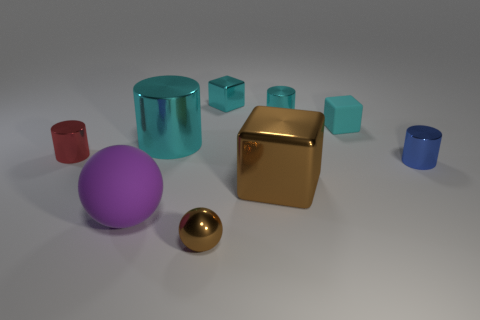How many small cyan matte things are to the right of the tiny cyan metallic object that is to the right of the brown thing behind the purple sphere? There is one small cyan matte cube to the right of the tiny cyan metallic sphere, which is in turn to the right of the large brown metallic cube located behind the large purple matte sphere. 